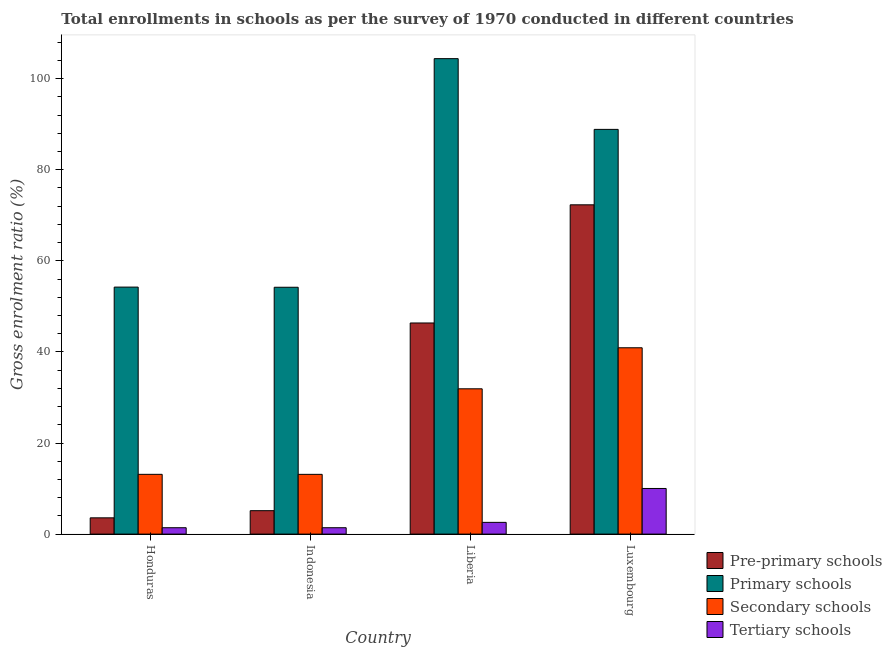How many different coloured bars are there?
Your response must be concise. 4. How many groups of bars are there?
Offer a very short reply. 4. Are the number of bars per tick equal to the number of legend labels?
Ensure brevity in your answer.  Yes. What is the label of the 1st group of bars from the left?
Offer a very short reply. Honduras. In how many cases, is the number of bars for a given country not equal to the number of legend labels?
Offer a terse response. 0. What is the gross enrolment ratio in primary schools in Honduras?
Ensure brevity in your answer.  54.24. Across all countries, what is the maximum gross enrolment ratio in primary schools?
Ensure brevity in your answer.  104.4. Across all countries, what is the minimum gross enrolment ratio in tertiary schools?
Your answer should be very brief. 1.4. In which country was the gross enrolment ratio in tertiary schools maximum?
Provide a succinct answer. Luxembourg. What is the total gross enrolment ratio in pre-primary schools in the graph?
Offer a very short reply. 127.38. What is the difference between the gross enrolment ratio in primary schools in Indonesia and that in Liberia?
Provide a short and direct response. -50.2. What is the difference between the gross enrolment ratio in pre-primary schools in Liberia and the gross enrolment ratio in primary schools in Honduras?
Your answer should be very brief. -7.88. What is the average gross enrolment ratio in pre-primary schools per country?
Give a very brief answer. 31.84. What is the difference between the gross enrolment ratio in pre-primary schools and gross enrolment ratio in tertiary schools in Honduras?
Make the answer very short. 2.17. In how many countries, is the gross enrolment ratio in pre-primary schools greater than 36 %?
Provide a short and direct response. 2. What is the ratio of the gross enrolment ratio in primary schools in Honduras to that in Luxembourg?
Give a very brief answer. 0.61. Is the difference between the gross enrolment ratio in pre-primary schools in Honduras and Liberia greater than the difference between the gross enrolment ratio in tertiary schools in Honduras and Liberia?
Give a very brief answer. No. What is the difference between the highest and the second highest gross enrolment ratio in secondary schools?
Your answer should be very brief. 9.01. What is the difference between the highest and the lowest gross enrolment ratio in secondary schools?
Make the answer very short. 27.8. In how many countries, is the gross enrolment ratio in primary schools greater than the average gross enrolment ratio in primary schools taken over all countries?
Offer a very short reply. 2. Is it the case that in every country, the sum of the gross enrolment ratio in secondary schools and gross enrolment ratio in tertiary schools is greater than the sum of gross enrolment ratio in primary schools and gross enrolment ratio in pre-primary schools?
Offer a terse response. Yes. What does the 1st bar from the left in Indonesia represents?
Provide a short and direct response. Pre-primary schools. What does the 2nd bar from the right in Liberia represents?
Make the answer very short. Secondary schools. Is it the case that in every country, the sum of the gross enrolment ratio in pre-primary schools and gross enrolment ratio in primary schools is greater than the gross enrolment ratio in secondary schools?
Your response must be concise. Yes. How many countries are there in the graph?
Offer a very short reply. 4. Does the graph contain any zero values?
Offer a terse response. No. Where does the legend appear in the graph?
Make the answer very short. Bottom right. How many legend labels are there?
Provide a short and direct response. 4. How are the legend labels stacked?
Offer a very short reply. Vertical. What is the title of the graph?
Ensure brevity in your answer.  Total enrollments in schools as per the survey of 1970 conducted in different countries. Does "Overall level" appear as one of the legend labels in the graph?
Provide a short and direct response. No. What is the label or title of the X-axis?
Offer a terse response. Country. What is the Gross enrolment ratio (%) in Pre-primary schools in Honduras?
Give a very brief answer. 3.57. What is the Gross enrolment ratio (%) of Primary schools in Honduras?
Offer a very short reply. 54.24. What is the Gross enrolment ratio (%) of Secondary schools in Honduras?
Your response must be concise. 13.12. What is the Gross enrolment ratio (%) in Tertiary schools in Honduras?
Keep it short and to the point. 1.4. What is the Gross enrolment ratio (%) in Pre-primary schools in Indonesia?
Offer a very short reply. 5.14. What is the Gross enrolment ratio (%) of Primary schools in Indonesia?
Your answer should be very brief. 54.2. What is the Gross enrolment ratio (%) of Secondary schools in Indonesia?
Offer a very short reply. 13.12. What is the Gross enrolment ratio (%) in Tertiary schools in Indonesia?
Offer a terse response. 1.4. What is the Gross enrolment ratio (%) of Pre-primary schools in Liberia?
Your response must be concise. 46.36. What is the Gross enrolment ratio (%) in Primary schools in Liberia?
Offer a terse response. 104.4. What is the Gross enrolment ratio (%) of Secondary schools in Liberia?
Provide a succinct answer. 31.9. What is the Gross enrolment ratio (%) of Tertiary schools in Liberia?
Your answer should be very brief. 2.58. What is the Gross enrolment ratio (%) in Pre-primary schools in Luxembourg?
Your answer should be compact. 72.3. What is the Gross enrolment ratio (%) of Primary schools in Luxembourg?
Give a very brief answer. 88.87. What is the Gross enrolment ratio (%) of Secondary schools in Luxembourg?
Give a very brief answer. 40.91. What is the Gross enrolment ratio (%) in Tertiary schools in Luxembourg?
Your response must be concise. 10.02. Across all countries, what is the maximum Gross enrolment ratio (%) in Pre-primary schools?
Offer a terse response. 72.3. Across all countries, what is the maximum Gross enrolment ratio (%) of Primary schools?
Offer a very short reply. 104.4. Across all countries, what is the maximum Gross enrolment ratio (%) of Secondary schools?
Offer a very short reply. 40.91. Across all countries, what is the maximum Gross enrolment ratio (%) of Tertiary schools?
Your answer should be compact. 10.02. Across all countries, what is the minimum Gross enrolment ratio (%) in Pre-primary schools?
Keep it short and to the point. 3.57. Across all countries, what is the minimum Gross enrolment ratio (%) of Primary schools?
Your answer should be very brief. 54.2. Across all countries, what is the minimum Gross enrolment ratio (%) of Secondary schools?
Your response must be concise. 13.12. Across all countries, what is the minimum Gross enrolment ratio (%) of Tertiary schools?
Ensure brevity in your answer.  1.4. What is the total Gross enrolment ratio (%) in Pre-primary schools in the graph?
Give a very brief answer. 127.38. What is the total Gross enrolment ratio (%) of Primary schools in the graph?
Provide a short and direct response. 301.7. What is the total Gross enrolment ratio (%) in Secondary schools in the graph?
Give a very brief answer. 99.06. What is the total Gross enrolment ratio (%) in Tertiary schools in the graph?
Make the answer very short. 15.4. What is the difference between the Gross enrolment ratio (%) in Pre-primary schools in Honduras and that in Indonesia?
Offer a terse response. -1.57. What is the difference between the Gross enrolment ratio (%) in Primary schools in Honduras and that in Indonesia?
Your response must be concise. 0.03. What is the difference between the Gross enrolment ratio (%) of Secondary schools in Honduras and that in Indonesia?
Give a very brief answer. 0. What is the difference between the Gross enrolment ratio (%) of Tertiary schools in Honduras and that in Indonesia?
Your answer should be very brief. 0. What is the difference between the Gross enrolment ratio (%) in Pre-primary schools in Honduras and that in Liberia?
Your response must be concise. -42.79. What is the difference between the Gross enrolment ratio (%) of Primary schools in Honduras and that in Liberia?
Offer a very short reply. -50.16. What is the difference between the Gross enrolment ratio (%) in Secondary schools in Honduras and that in Liberia?
Ensure brevity in your answer.  -18.78. What is the difference between the Gross enrolment ratio (%) in Tertiary schools in Honduras and that in Liberia?
Ensure brevity in your answer.  -1.18. What is the difference between the Gross enrolment ratio (%) of Pre-primary schools in Honduras and that in Luxembourg?
Provide a short and direct response. -68.73. What is the difference between the Gross enrolment ratio (%) of Primary schools in Honduras and that in Luxembourg?
Your response must be concise. -34.63. What is the difference between the Gross enrolment ratio (%) of Secondary schools in Honduras and that in Luxembourg?
Make the answer very short. -27.79. What is the difference between the Gross enrolment ratio (%) of Tertiary schools in Honduras and that in Luxembourg?
Offer a terse response. -8.62. What is the difference between the Gross enrolment ratio (%) of Pre-primary schools in Indonesia and that in Liberia?
Keep it short and to the point. -41.22. What is the difference between the Gross enrolment ratio (%) of Primary schools in Indonesia and that in Liberia?
Offer a very short reply. -50.2. What is the difference between the Gross enrolment ratio (%) in Secondary schools in Indonesia and that in Liberia?
Offer a very short reply. -18.79. What is the difference between the Gross enrolment ratio (%) in Tertiary schools in Indonesia and that in Liberia?
Your answer should be very brief. -1.18. What is the difference between the Gross enrolment ratio (%) in Pre-primary schools in Indonesia and that in Luxembourg?
Provide a short and direct response. -67.16. What is the difference between the Gross enrolment ratio (%) of Primary schools in Indonesia and that in Luxembourg?
Ensure brevity in your answer.  -34.67. What is the difference between the Gross enrolment ratio (%) of Secondary schools in Indonesia and that in Luxembourg?
Ensure brevity in your answer.  -27.8. What is the difference between the Gross enrolment ratio (%) in Tertiary schools in Indonesia and that in Luxembourg?
Your response must be concise. -8.62. What is the difference between the Gross enrolment ratio (%) of Pre-primary schools in Liberia and that in Luxembourg?
Offer a very short reply. -25.94. What is the difference between the Gross enrolment ratio (%) of Primary schools in Liberia and that in Luxembourg?
Your answer should be very brief. 15.53. What is the difference between the Gross enrolment ratio (%) of Secondary schools in Liberia and that in Luxembourg?
Your response must be concise. -9.01. What is the difference between the Gross enrolment ratio (%) of Tertiary schools in Liberia and that in Luxembourg?
Give a very brief answer. -7.44. What is the difference between the Gross enrolment ratio (%) in Pre-primary schools in Honduras and the Gross enrolment ratio (%) in Primary schools in Indonesia?
Give a very brief answer. -50.63. What is the difference between the Gross enrolment ratio (%) of Pre-primary schools in Honduras and the Gross enrolment ratio (%) of Secondary schools in Indonesia?
Your response must be concise. -9.55. What is the difference between the Gross enrolment ratio (%) of Pre-primary schools in Honduras and the Gross enrolment ratio (%) of Tertiary schools in Indonesia?
Ensure brevity in your answer.  2.17. What is the difference between the Gross enrolment ratio (%) of Primary schools in Honduras and the Gross enrolment ratio (%) of Secondary schools in Indonesia?
Keep it short and to the point. 41.12. What is the difference between the Gross enrolment ratio (%) of Primary schools in Honduras and the Gross enrolment ratio (%) of Tertiary schools in Indonesia?
Ensure brevity in your answer.  52.84. What is the difference between the Gross enrolment ratio (%) in Secondary schools in Honduras and the Gross enrolment ratio (%) in Tertiary schools in Indonesia?
Provide a succinct answer. 11.72. What is the difference between the Gross enrolment ratio (%) of Pre-primary schools in Honduras and the Gross enrolment ratio (%) of Primary schools in Liberia?
Your answer should be very brief. -100.83. What is the difference between the Gross enrolment ratio (%) of Pre-primary schools in Honduras and the Gross enrolment ratio (%) of Secondary schools in Liberia?
Your answer should be compact. -28.33. What is the difference between the Gross enrolment ratio (%) of Pre-primary schools in Honduras and the Gross enrolment ratio (%) of Tertiary schools in Liberia?
Your answer should be very brief. 0.99. What is the difference between the Gross enrolment ratio (%) in Primary schools in Honduras and the Gross enrolment ratio (%) in Secondary schools in Liberia?
Your answer should be compact. 22.33. What is the difference between the Gross enrolment ratio (%) in Primary schools in Honduras and the Gross enrolment ratio (%) in Tertiary schools in Liberia?
Provide a succinct answer. 51.66. What is the difference between the Gross enrolment ratio (%) in Secondary schools in Honduras and the Gross enrolment ratio (%) in Tertiary schools in Liberia?
Offer a very short reply. 10.55. What is the difference between the Gross enrolment ratio (%) in Pre-primary schools in Honduras and the Gross enrolment ratio (%) in Primary schools in Luxembourg?
Your answer should be very brief. -85.3. What is the difference between the Gross enrolment ratio (%) in Pre-primary schools in Honduras and the Gross enrolment ratio (%) in Secondary schools in Luxembourg?
Offer a very short reply. -37.34. What is the difference between the Gross enrolment ratio (%) in Pre-primary schools in Honduras and the Gross enrolment ratio (%) in Tertiary schools in Luxembourg?
Your answer should be very brief. -6.45. What is the difference between the Gross enrolment ratio (%) of Primary schools in Honduras and the Gross enrolment ratio (%) of Secondary schools in Luxembourg?
Make the answer very short. 13.32. What is the difference between the Gross enrolment ratio (%) in Primary schools in Honduras and the Gross enrolment ratio (%) in Tertiary schools in Luxembourg?
Provide a succinct answer. 44.22. What is the difference between the Gross enrolment ratio (%) in Secondary schools in Honduras and the Gross enrolment ratio (%) in Tertiary schools in Luxembourg?
Provide a short and direct response. 3.1. What is the difference between the Gross enrolment ratio (%) of Pre-primary schools in Indonesia and the Gross enrolment ratio (%) of Primary schools in Liberia?
Ensure brevity in your answer.  -99.26. What is the difference between the Gross enrolment ratio (%) in Pre-primary schools in Indonesia and the Gross enrolment ratio (%) in Secondary schools in Liberia?
Your answer should be compact. -26.76. What is the difference between the Gross enrolment ratio (%) in Pre-primary schools in Indonesia and the Gross enrolment ratio (%) in Tertiary schools in Liberia?
Provide a short and direct response. 2.56. What is the difference between the Gross enrolment ratio (%) in Primary schools in Indonesia and the Gross enrolment ratio (%) in Secondary schools in Liberia?
Make the answer very short. 22.3. What is the difference between the Gross enrolment ratio (%) in Primary schools in Indonesia and the Gross enrolment ratio (%) in Tertiary schools in Liberia?
Ensure brevity in your answer.  51.62. What is the difference between the Gross enrolment ratio (%) of Secondary schools in Indonesia and the Gross enrolment ratio (%) of Tertiary schools in Liberia?
Offer a very short reply. 10.54. What is the difference between the Gross enrolment ratio (%) of Pre-primary schools in Indonesia and the Gross enrolment ratio (%) of Primary schools in Luxembourg?
Make the answer very short. -83.72. What is the difference between the Gross enrolment ratio (%) of Pre-primary schools in Indonesia and the Gross enrolment ratio (%) of Secondary schools in Luxembourg?
Provide a short and direct response. -35.77. What is the difference between the Gross enrolment ratio (%) of Pre-primary schools in Indonesia and the Gross enrolment ratio (%) of Tertiary schools in Luxembourg?
Keep it short and to the point. -4.88. What is the difference between the Gross enrolment ratio (%) in Primary schools in Indonesia and the Gross enrolment ratio (%) in Secondary schools in Luxembourg?
Give a very brief answer. 13.29. What is the difference between the Gross enrolment ratio (%) of Primary schools in Indonesia and the Gross enrolment ratio (%) of Tertiary schools in Luxembourg?
Offer a terse response. 44.18. What is the difference between the Gross enrolment ratio (%) of Secondary schools in Indonesia and the Gross enrolment ratio (%) of Tertiary schools in Luxembourg?
Give a very brief answer. 3.1. What is the difference between the Gross enrolment ratio (%) in Pre-primary schools in Liberia and the Gross enrolment ratio (%) in Primary schools in Luxembourg?
Offer a very short reply. -42.51. What is the difference between the Gross enrolment ratio (%) of Pre-primary schools in Liberia and the Gross enrolment ratio (%) of Secondary schools in Luxembourg?
Offer a terse response. 5.44. What is the difference between the Gross enrolment ratio (%) in Pre-primary schools in Liberia and the Gross enrolment ratio (%) in Tertiary schools in Luxembourg?
Provide a short and direct response. 36.34. What is the difference between the Gross enrolment ratio (%) in Primary schools in Liberia and the Gross enrolment ratio (%) in Secondary schools in Luxembourg?
Keep it short and to the point. 63.48. What is the difference between the Gross enrolment ratio (%) in Primary schools in Liberia and the Gross enrolment ratio (%) in Tertiary schools in Luxembourg?
Your answer should be very brief. 94.38. What is the difference between the Gross enrolment ratio (%) of Secondary schools in Liberia and the Gross enrolment ratio (%) of Tertiary schools in Luxembourg?
Provide a succinct answer. 21.89. What is the average Gross enrolment ratio (%) in Pre-primary schools per country?
Your answer should be compact. 31.84. What is the average Gross enrolment ratio (%) in Primary schools per country?
Your answer should be compact. 75.43. What is the average Gross enrolment ratio (%) in Secondary schools per country?
Your answer should be compact. 24.77. What is the average Gross enrolment ratio (%) of Tertiary schools per country?
Provide a short and direct response. 3.85. What is the difference between the Gross enrolment ratio (%) in Pre-primary schools and Gross enrolment ratio (%) in Primary schools in Honduras?
Your answer should be compact. -50.66. What is the difference between the Gross enrolment ratio (%) of Pre-primary schools and Gross enrolment ratio (%) of Secondary schools in Honduras?
Provide a succinct answer. -9.55. What is the difference between the Gross enrolment ratio (%) in Pre-primary schools and Gross enrolment ratio (%) in Tertiary schools in Honduras?
Your response must be concise. 2.17. What is the difference between the Gross enrolment ratio (%) of Primary schools and Gross enrolment ratio (%) of Secondary schools in Honduras?
Provide a short and direct response. 41.11. What is the difference between the Gross enrolment ratio (%) in Primary schools and Gross enrolment ratio (%) in Tertiary schools in Honduras?
Provide a short and direct response. 52.83. What is the difference between the Gross enrolment ratio (%) of Secondary schools and Gross enrolment ratio (%) of Tertiary schools in Honduras?
Your response must be concise. 11.72. What is the difference between the Gross enrolment ratio (%) of Pre-primary schools and Gross enrolment ratio (%) of Primary schools in Indonesia?
Offer a very short reply. -49.06. What is the difference between the Gross enrolment ratio (%) in Pre-primary schools and Gross enrolment ratio (%) in Secondary schools in Indonesia?
Offer a terse response. -7.98. What is the difference between the Gross enrolment ratio (%) of Pre-primary schools and Gross enrolment ratio (%) of Tertiary schools in Indonesia?
Give a very brief answer. 3.74. What is the difference between the Gross enrolment ratio (%) of Primary schools and Gross enrolment ratio (%) of Secondary schools in Indonesia?
Provide a short and direct response. 41.08. What is the difference between the Gross enrolment ratio (%) in Primary schools and Gross enrolment ratio (%) in Tertiary schools in Indonesia?
Give a very brief answer. 52.8. What is the difference between the Gross enrolment ratio (%) of Secondary schools and Gross enrolment ratio (%) of Tertiary schools in Indonesia?
Make the answer very short. 11.72. What is the difference between the Gross enrolment ratio (%) of Pre-primary schools and Gross enrolment ratio (%) of Primary schools in Liberia?
Offer a very short reply. -58.04. What is the difference between the Gross enrolment ratio (%) in Pre-primary schools and Gross enrolment ratio (%) in Secondary schools in Liberia?
Offer a very short reply. 14.45. What is the difference between the Gross enrolment ratio (%) in Pre-primary schools and Gross enrolment ratio (%) in Tertiary schools in Liberia?
Keep it short and to the point. 43.78. What is the difference between the Gross enrolment ratio (%) in Primary schools and Gross enrolment ratio (%) in Secondary schools in Liberia?
Ensure brevity in your answer.  72.49. What is the difference between the Gross enrolment ratio (%) in Primary schools and Gross enrolment ratio (%) in Tertiary schools in Liberia?
Provide a short and direct response. 101.82. What is the difference between the Gross enrolment ratio (%) in Secondary schools and Gross enrolment ratio (%) in Tertiary schools in Liberia?
Your answer should be very brief. 29.33. What is the difference between the Gross enrolment ratio (%) of Pre-primary schools and Gross enrolment ratio (%) of Primary schools in Luxembourg?
Make the answer very short. -16.56. What is the difference between the Gross enrolment ratio (%) of Pre-primary schools and Gross enrolment ratio (%) of Secondary schools in Luxembourg?
Make the answer very short. 31.39. What is the difference between the Gross enrolment ratio (%) in Pre-primary schools and Gross enrolment ratio (%) in Tertiary schools in Luxembourg?
Your answer should be very brief. 62.28. What is the difference between the Gross enrolment ratio (%) in Primary schools and Gross enrolment ratio (%) in Secondary schools in Luxembourg?
Your response must be concise. 47.95. What is the difference between the Gross enrolment ratio (%) in Primary schools and Gross enrolment ratio (%) in Tertiary schools in Luxembourg?
Your answer should be compact. 78.85. What is the difference between the Gross enrolment ratio (%) in Secondary schools and Gross enrolment ratio (%) in Tertiary schools in Luxembourg?
Offer a terse response. 30.9. What is the ratio of the Gross enrolment ratio (%) in Pre-primary schools in Honduras to that in Indonesia?
Ensure brevity in your answer.  0.69. What is the ratio of the Gross enrolment ratio (%) of Secondary schools in Honduras to that in Indonesia?
Provide a succinct answer. 1. What is the ratio of the Gross enrolment ratio (%) of Pre-primary schools in Honduras to that in Liberia?
Keep it short and to the point. 0.08. What is the ratio of the Gross enrolment ratio (%) of Primary schools in Honduras to that in Liberia?
Ensure brevity in your answer.  0.52. What is the ratio of the Gross enrolment ratio (%) of Secondary schools in Honduras to that in Liberia?
Provide a short and direct response. 0.41. What is the ratio of the Gross enrolment ratio (%) in Tertiary schools in Honduras to that in Liberia?
Offer a very short reply. 0.54. What is the ratio of the Gross enrolment ratio (%) in Pre-primary schools in Honduras to that in Luxembourg?
Provide a short and direct response. 0.05. What is the ratio of the Gross enrolment ratio (%) of Primary schools in Honduras to that in Luxembourg?
Keep it short and to the point. 0.61. What is the ratio of the Gross enrolment ratio (%) in Secondary schools in Honduras to that in Luxembourg?
Offer a terse response. 0.32. What is the ratio of the Gross enrolment ratio (%) in Tertiary schools in Honduras to that in Luxembourg?
Your answer should be compact. 0.14. What is the ratio of the Gross enrolment ratio (%) in Pre-primary schools in Indonesia to that in Liberia?
Your answer should be compact. 0.11. What is the ratio of the Gross enrolment ratio (%) in Primary schools in Indonesia to that in Liberia?
Offer a very short reply. 0.52. What is the ratio of the Gross enrolment ratio (%) of Secondary schools in Indonesia to that in Liberia?
Offer a terse response. 0.41. What is the ratio of the Gross enrolment ratio (%) in Tertiary schools in Indonesia to that in Liberia?
Give a very brief answer. 0.54. What is the ratio of the Gross enrolment ratio (%) in Pre-primary schools in Indonesia to that in Luxembourg?
Offer a terse response. 0.07. What is the ratio of the Gross enrolment ratio (%) of Primary schools in Indonesia to that in Luxembourg?
Your answer should be compact. 0.61. What is the ratio of the Gross enrolment ratio (%) in Secondary schools in Indonesia to that in Luxembourg?
Your answer should be compact. 0.32. What is the ratio of the Gross enrolment ratio (%) in Tertiary schools in Indonesia to that in Luxembourg?
Offer a terse response. 0.14. What is the ratio of the Gross enrolment ratio (%) of Pre-primary schools in Liberia to that in Luxembourg?
Your answer should be very brief. 0.64. What is the ratio of the Gross enrolment ratio (%) of Primary schools in Liberia to that in Luxembourg?
Offer a very short reply. 1.17. What is the ratio of the Gross enrolment ratio (%) in Secondary schools in Liberia to that in Luxembourg?
Offer a very short reply. 0.78. What is the ratio of the Gross enrolment ratio (%) in Tertiary schools in Liberia to that in Luxembourg?
Keep it short and to the point. 0.26. What is the difference between the highest and the second highest Gross enrolment ratio (%) of Pre-primary schools?
Keep it short and to the point. 25.94. What is the difference between the highest and the second highest Gross enrolment ratio (%) of Primary schools?
Offer a very short reply. 15.53. What is the difference between the highest and the second highest Gross enrolment ratio (%) in Secondary schools?
Make the answer very short. 9.01. What is the difference between the highest and the second highest Gross enrolment ratio (%) in Tertiary schools?
Offer a very short reply. 7.44. What is the difference between the highest and the lowest Gross enrolment ratio (%) of Pre-primary schools?
Provide a succinct answer. 68.73. What is the difference between the highest and the lowest Gross enrolment ratio (%) in Primary schools?
Your answer should be very brief. 50.2. What is the difference between the highest and the lowest Gross enrolment ratio (%) of Secondary schools?
Your response must be concise. 27.8. What is the difference between the highest and the lowest Gross enrolment ratio (%) of Tertiary schools?
Provide a short and direct response. 8.62. 